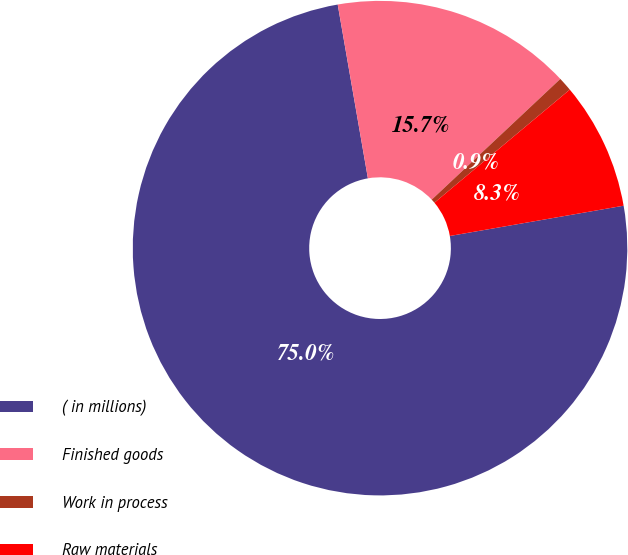Convert chart to OTSL. <chart><loc_0><loc_0><loc_500><loc_500><pie_chart><fcel>( in millions)<fcel>Finished goods<fcel>Work in process<fcel>Raw materials<nl><fcel>75.0%<fcel>15.74%<fcel>0.92%<fcel>8.33%<nl></chart> 